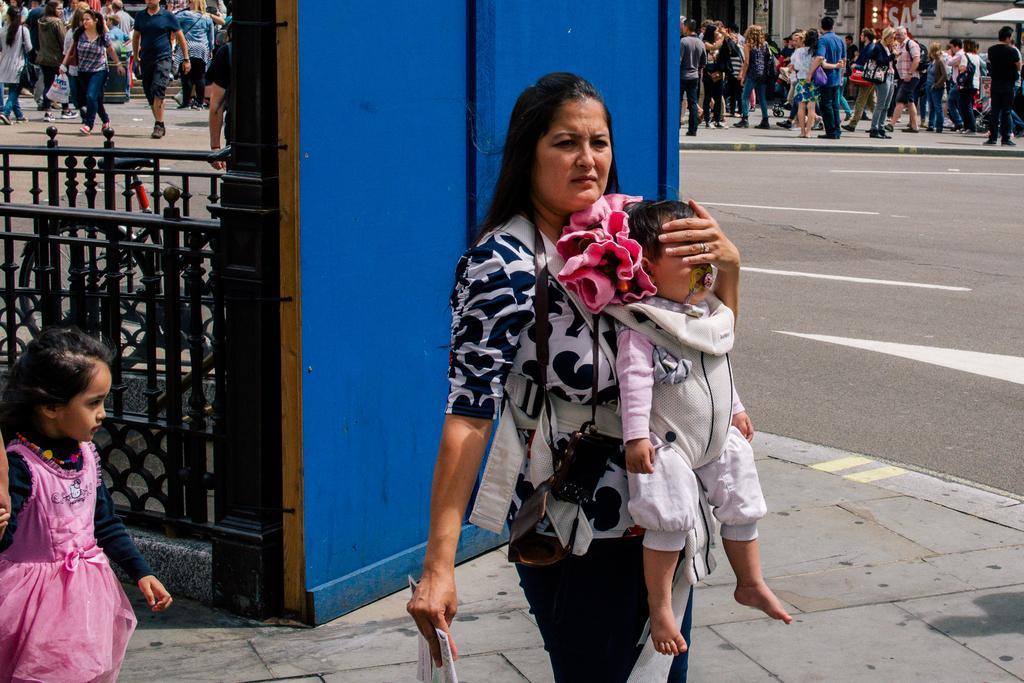How would you summarize this image in a sentence or two? This woman is holding an object and carrying baby. Here we can see girl. Beside this girl there is a grill. This is blue wall. Far there are people. 